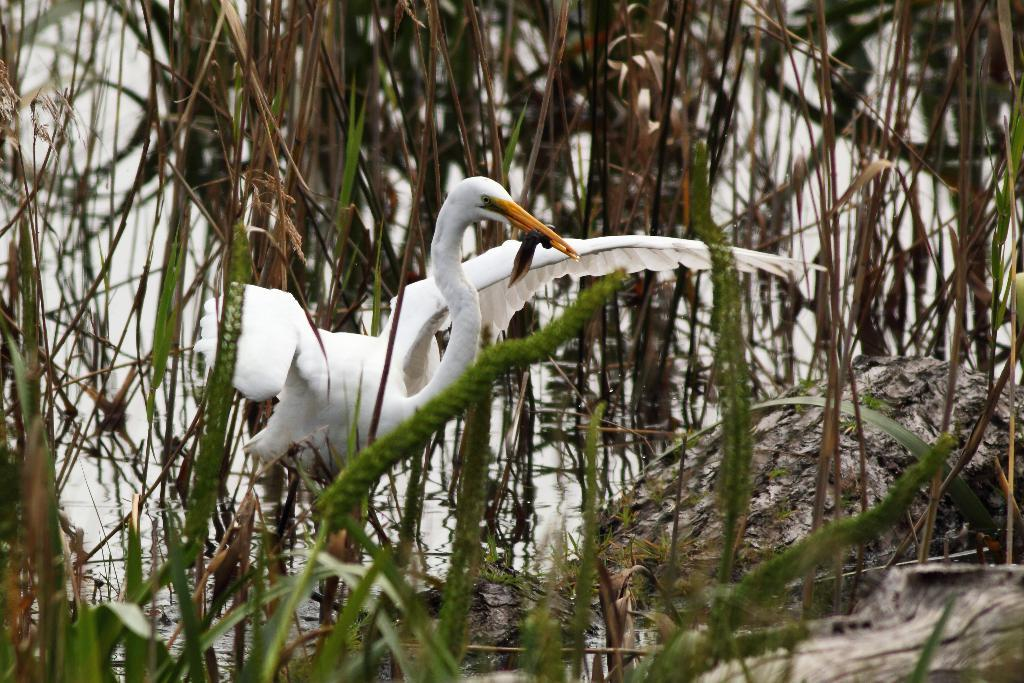What type of living organisms can be seen in the image? Plants are visible in the image. What animal is located in the middle of the image? There is an egret in the middle of the image. What is visible at the bottom of the image? Water is visible at the bottom of the image. What type of trail can be seen in the image? There is no trail present in the image. What phase of the moon is visible in the image? The moon is not visible in the image. 